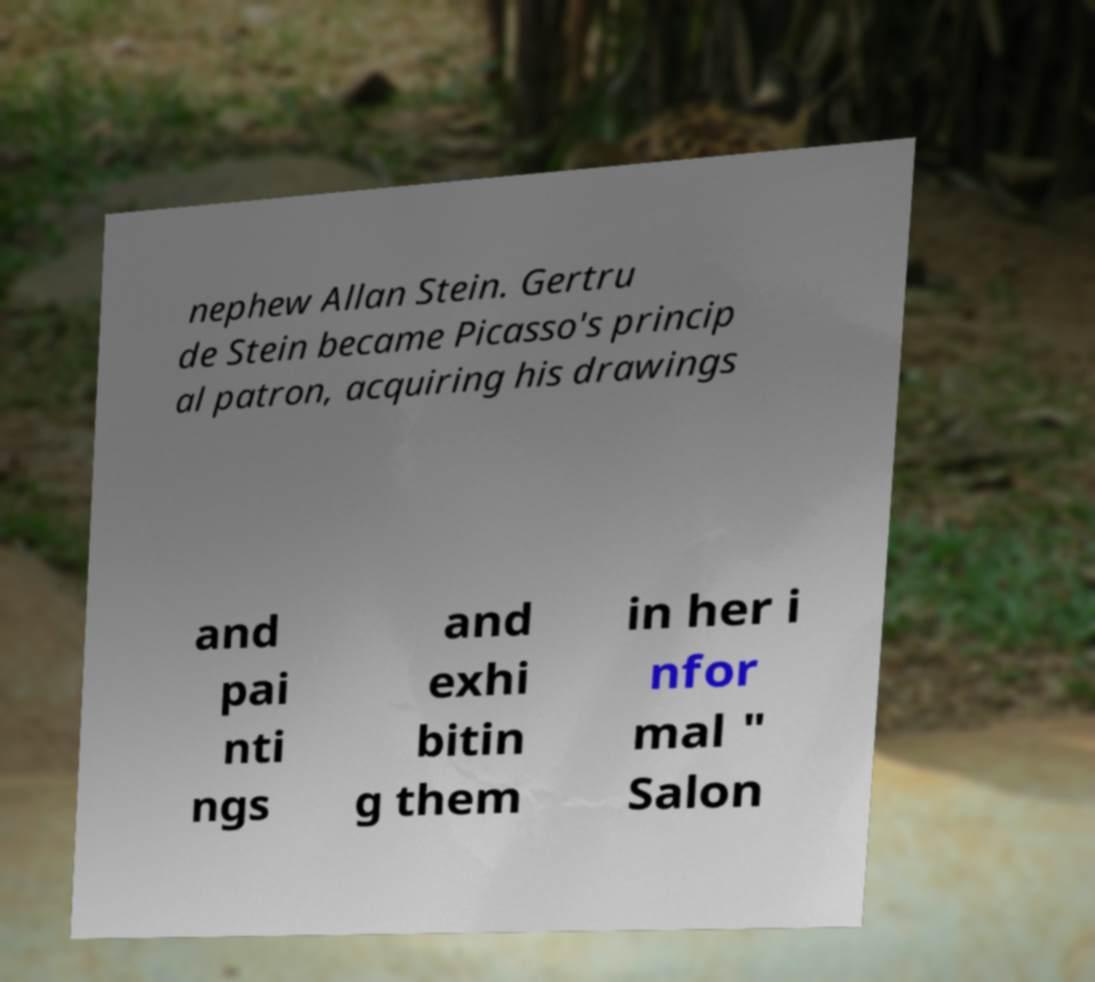Can you accurately transcribe the text from the provided image for me? nephew Allan Stein. Gertru de Stein became Picasso's princip al patron, acquiring his drawings and pai nti ngs and exhi bitin g them in her i nfor mal " Salon 